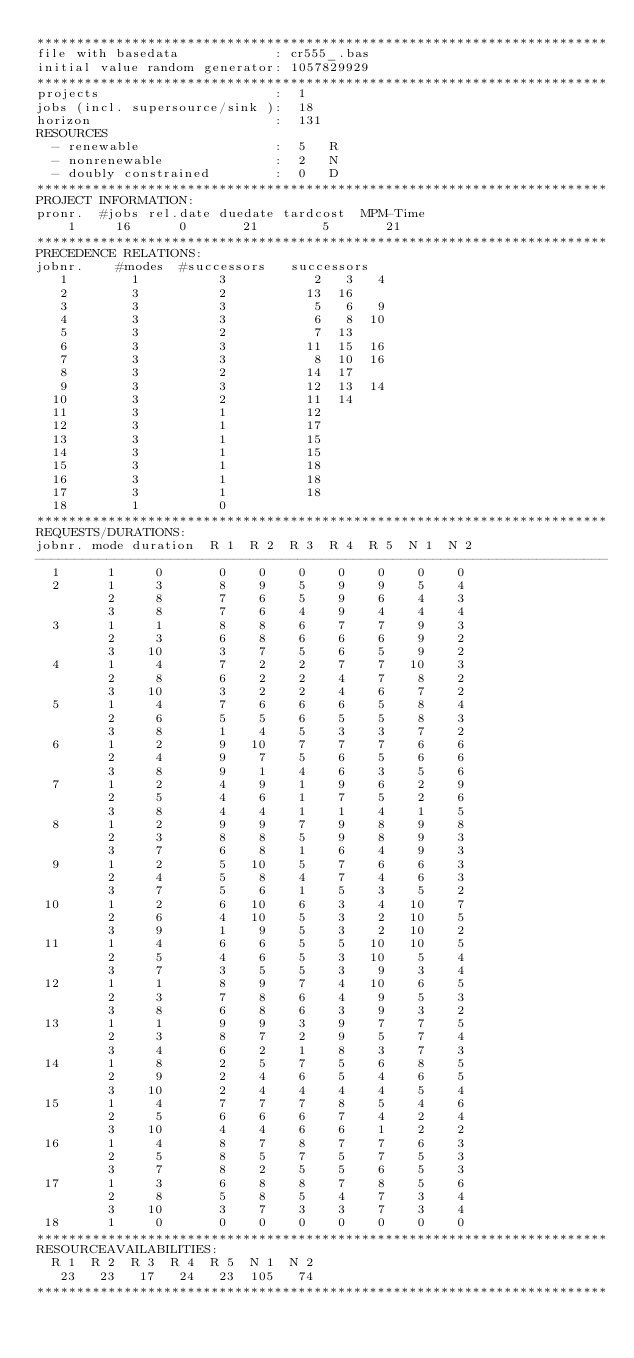<code> <loc_0><loc_0><loc_500><loc_500><_ObjectiveC_>************************************************************************
file with basedata            : cr555_.bas
initial value random generator: 1057829929
************************************************************************
projects                      :  1
jobs (incl. supersource/sink ):  18
horizon                       :  131
RESOURCES
  - renewable                 :  5   R
  - nonrenewable              :  2   N
  - doubly constrained        :  0   D
************************************************************************
PROJECT INFORMATION:
pronr.  #jobs rel.date duedate tardcost  MPM-Time
    1     16      0       21        5       21
************************************************************************
PRECEDENCE RELATIONS:
jobnr.    #modes  #successors   successors
   1        1          3           2   3   4
   2        3          2          13  16
   3        3          3           5   6   9
   4        3          3           6   8  10
   5        3          2           7  13
   6        3          3          11  15  16
   7        3          3           8  10  16
   8        3          2          14  17
   9        3          3          12  13  14
  10        3          2          11  14
  11        3          1          12
  12        3          1          17
  13        3          1          15
  14        3          1          15
  15        3          1          18
  16        3          1          18
  17        3          1          18
  18        1          0        
************************************************************************
REQUESTS/DURATIONS:
jobnr. mode duration  R 1  R 2  R 3  R 4  R 5  N 1  N 2
------------------------------------------------------------------------
  1      1     0       0    0    0    0    0    0    0
  2      1     3       8    9    5    9    9    5    4
         2     8       7    6    5    9    6    4    3
         3     8       7    6    4    9    4    4    4
  3      1     1       8    8    6    7    7    9    3
         2     3       6    8    6    6    6    9    2
         3    10       3    7    5    6    5    9    2
  4      1     4       7    2    2    7    7   10    3
         2     8       6    2    2    4    7    8    2
         3    10       3    2    2    4    6    7    2
  5      1     4       7    6    6    6    5    8    4
         2     6       5    5    6    5    5    8    3
         3     8       1    4    5    3    3    7    2
  6      1     2       9   10    7    7    7    6    6
         2     4       9    7    5    6    5    6    6
         3     8       9    1    4    6    3    5    6
  7      1     2       4    9    1    9    6    2    9
         2     5       4    6    1    7    5    2    6
         3     8       4    4    1    1    4    1    5
  8      1     2       9    9    7    9    8    9    8
         2     3       8    8    5    9    8    9    3
         3     7       6    8    1    6    4    9    3
  9      1     2       5   10    5    7    6    6    3
         2     4       5    8    4    7    4    6    3
         3     7       5    6    1    5    3    5    2
 10      1     2       6   10    6    3    4   10    7
         2     6       4   10    5    3    2   10    5
         3     9       1    9    5    3    2   10    2
 11      1     4       6    6    5    5   10   10    5
         2     5       4    6    5    3   10    5    4
         3     7       3    5    5    3    9    3    4
 12      1     1       8    9    7    4   10    6    5
         2     3       7    8    6    4    9    5    3
         3     8       6    8    6    3    9    3    2
 13      1     1       9    9    3    9    7    7    5
         2     3       8    7    2    9    5    7    4
         3     4       6    2    1    8    3    7    3
 14      1     8       2    5    7    5    6    8    5
         2     9       2    4    6    5    4    6    5
         3    10       2    4    4    4    4    5    4
 15      1     4       7    7    7    8    5    4    6
         2     5       6    6    6    7    4    2    4
         3    10       4    4    6    6    1    2    2
 16      1     4       8    7    8    7    7    6    3
         2     5       8    5    7    5    7    5    3
         3     7       8    2    5    5    6    5    3
 17      1     3       6    8    8    7    8    5    6
         2     8       5    8    5    4    7    3    4
         3    10       3    7    3    3    7    3    4
 18      1     0       0    0    0    0    0    0    0
************************************************************************
RESOURCEAVAILABILITIES:
  R 1  R 2  R 3  R 4  R 5  N 1  N 2
   23   23   17   24   23  105   74
************************************************************************
</code> 